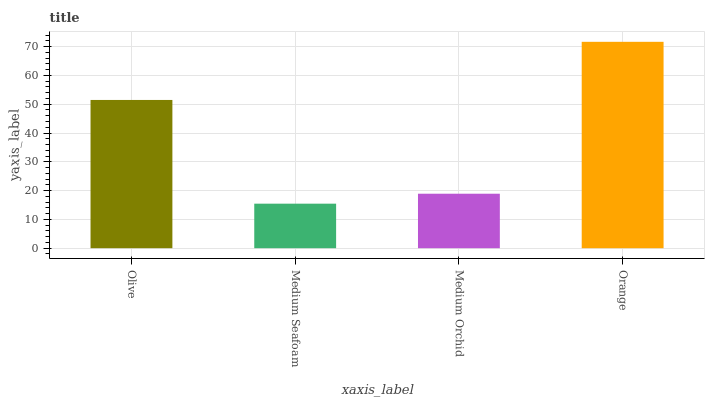Is Medium Orchid the minimum?
Answer yes or no. No. Is Medium Orchid the maximum?
Answer yes or no. No. Is Medium Orchid greater than Medium Seafoam?
Answer yes or no. Yes. Is Medium Seafoam less than Medium Orchid?
Answer yes or no. Yes. Is Medium Seafoam greater than Medium Orchid?
Answer yes or no. No. Is Medium Orchid less than Medium Seafoam?
Answer yes or no. No. Is Olive the high median?
Answer yes or no. Yes. Is Medium Orchid the low median?
Answer yes or no. Yes. Is Medium Orchid the high median?
Answer yes or no. No. Is Olive the low median?
Answer yes or no. No. 